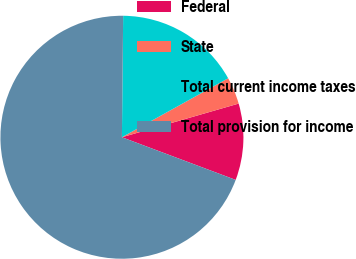<chart> <loc_0><loc_0><loc_500><loc_500><pie_chart><fcel>Federal<fcel>State<fcel>Total current income taxes<fcel>Total provision for income<nl><fcel>10.18%<fcel>3.6%<fcel>16.77%<fcel>69.46%<nl></chart> 